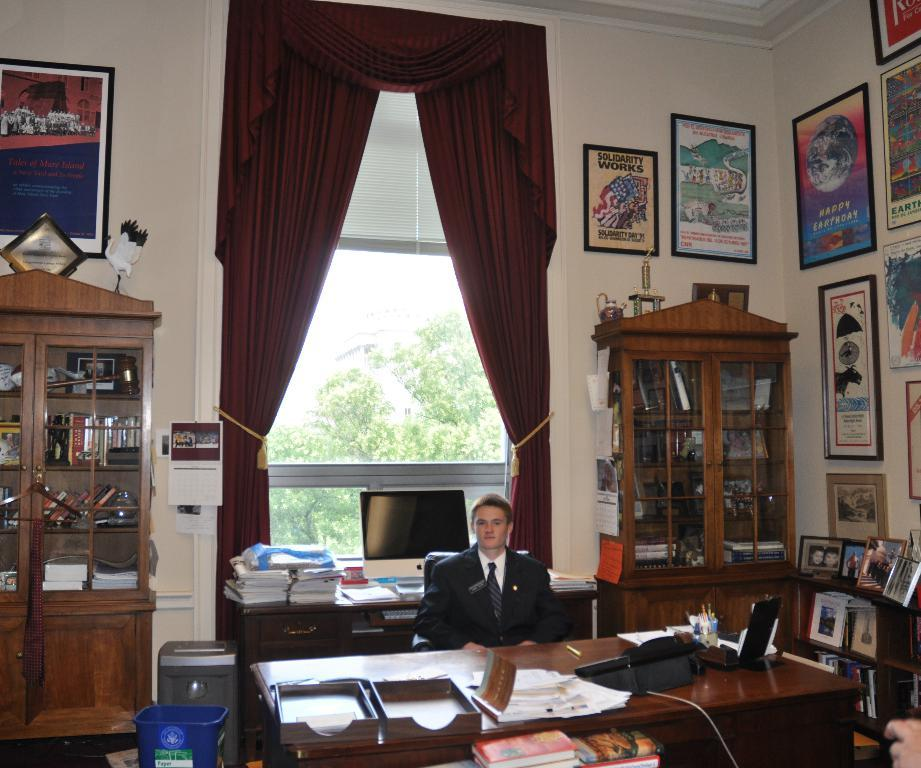<image>
Summarize the visual content of the image. A man sitting in a room with a framed flyer on the wall that says 'solidarity works' 